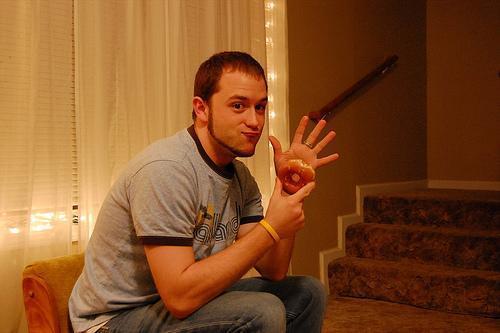How many people are in the photo?
Give a very brief answer. 1. 